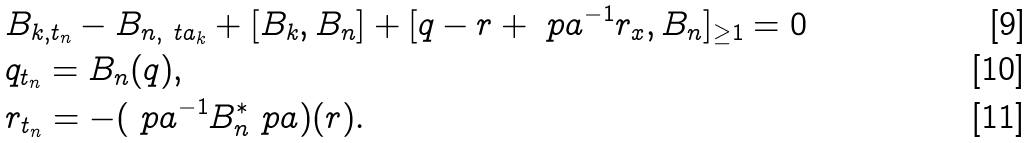<formula> <loc_0><loc_0><loc_500><loc_500>& B _ { k , t _ { n } } - B _ { n , \ t a _ { k } } + [ B _ { k } , B _ { n } ] + [ q - r + \ p a ^ { - 1 } r _ { x } , B _ { n } ] _ { \geq 1 } = 0 \\ & q _ { t _ { n } } = B _ { n } ( q ) , \\ & r _ { t _ { n } } = - ( \ p a ^ { - 1 } B _ { n } ^ { * } \ p a ) ( r ) .</formula> 